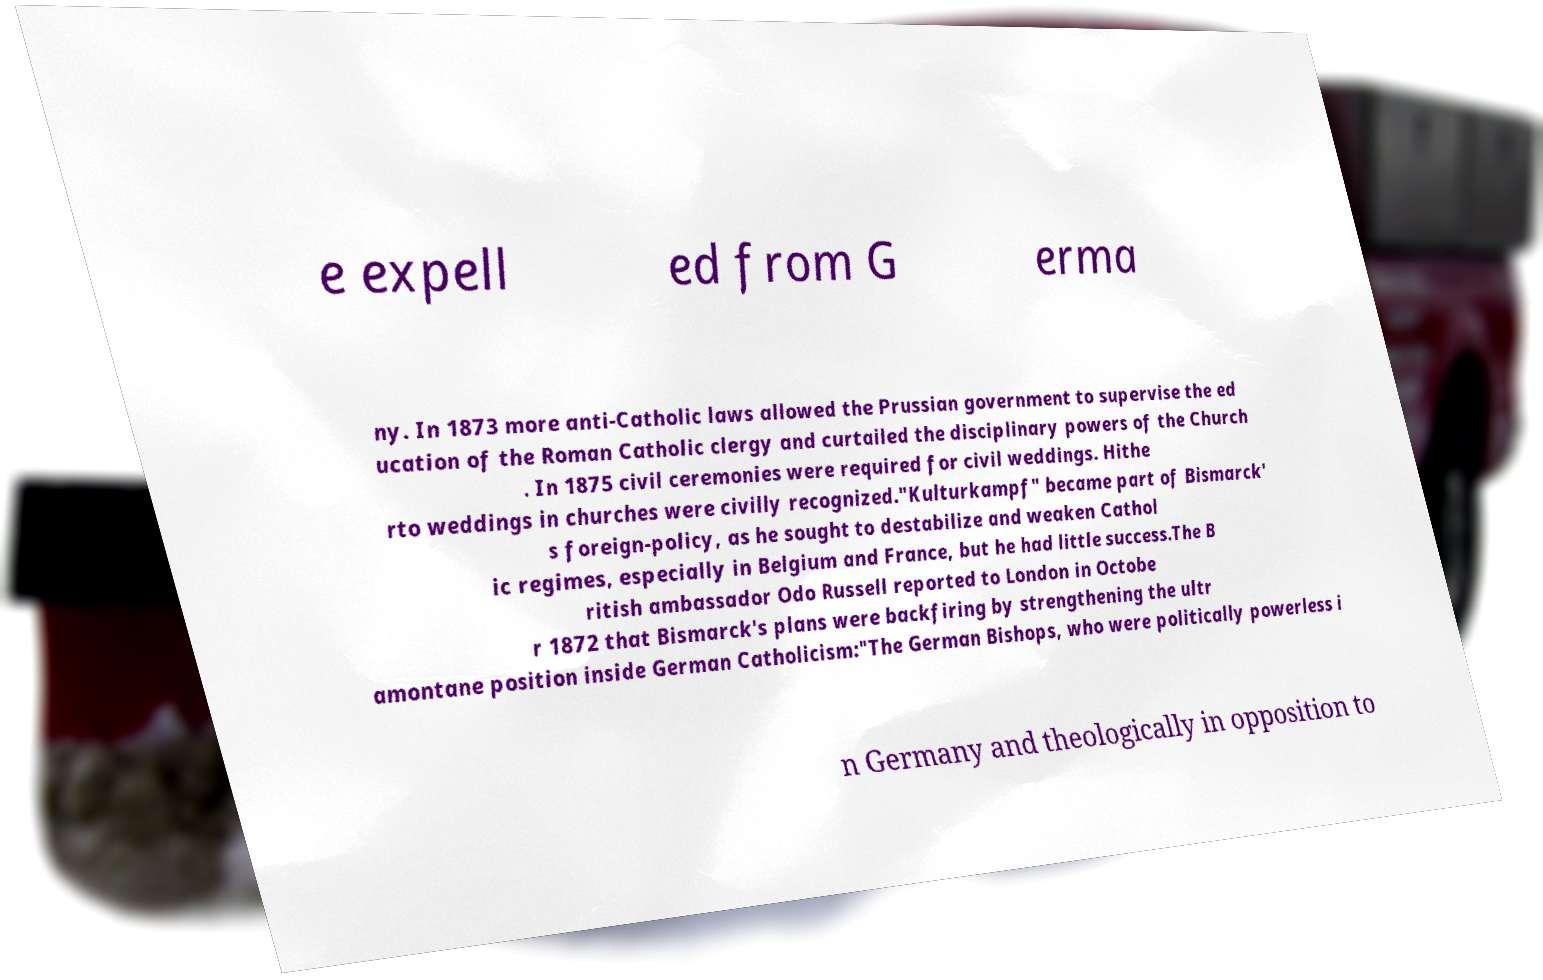Can you accurately transcribe the text from the provided image for me? e expell ed from G erma ny. In 1873 more anti-Catholic laws allowed the Prussian government to supervise the ed ucation of the Roman Catholic clergy and curtailed the disciplinary powers of the Church . In 1875 civil ceremonies were required for civil weddings. Hithe rto weddings in churches were civilly recognized."Kulturkampf" became part of Bismarck' s foreign-policy, as he sought to destabilize and weaken Cathol ic regimes, especially in Belgium and France, but he had little success.The B ritish ambassador Odo Russell reported to London in Octobe r 1872 that Bismarck's plans were backfiring by strengthening the ultr amontane position inside German Catholicism:"The German Bishops, who were politically powerless i n Germany and theologically in opposition to 